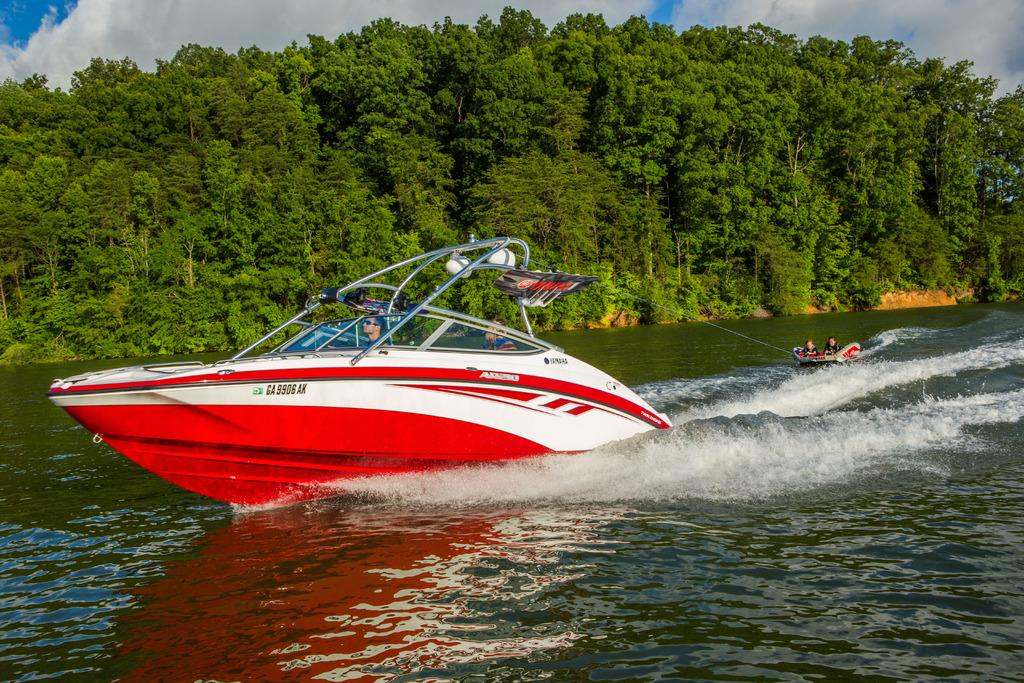What is the main subject in the foreground of the image? There is a boat in the foreground of the image. What is connected to the boat in the image? A raft is tied to the boat. What is the boat and raft doing in the image? The boat and raft are moving on the water. What can be seen in the background of the image? There are trees and the sky visible in the background of the image. What is the condition of the sky in the image? The sky has clouds in it. What type of voice can be heard coming from the boat in the image? There is no indication of any voice or sound in the image, as it only shows a boat and a raft moving on the water. 